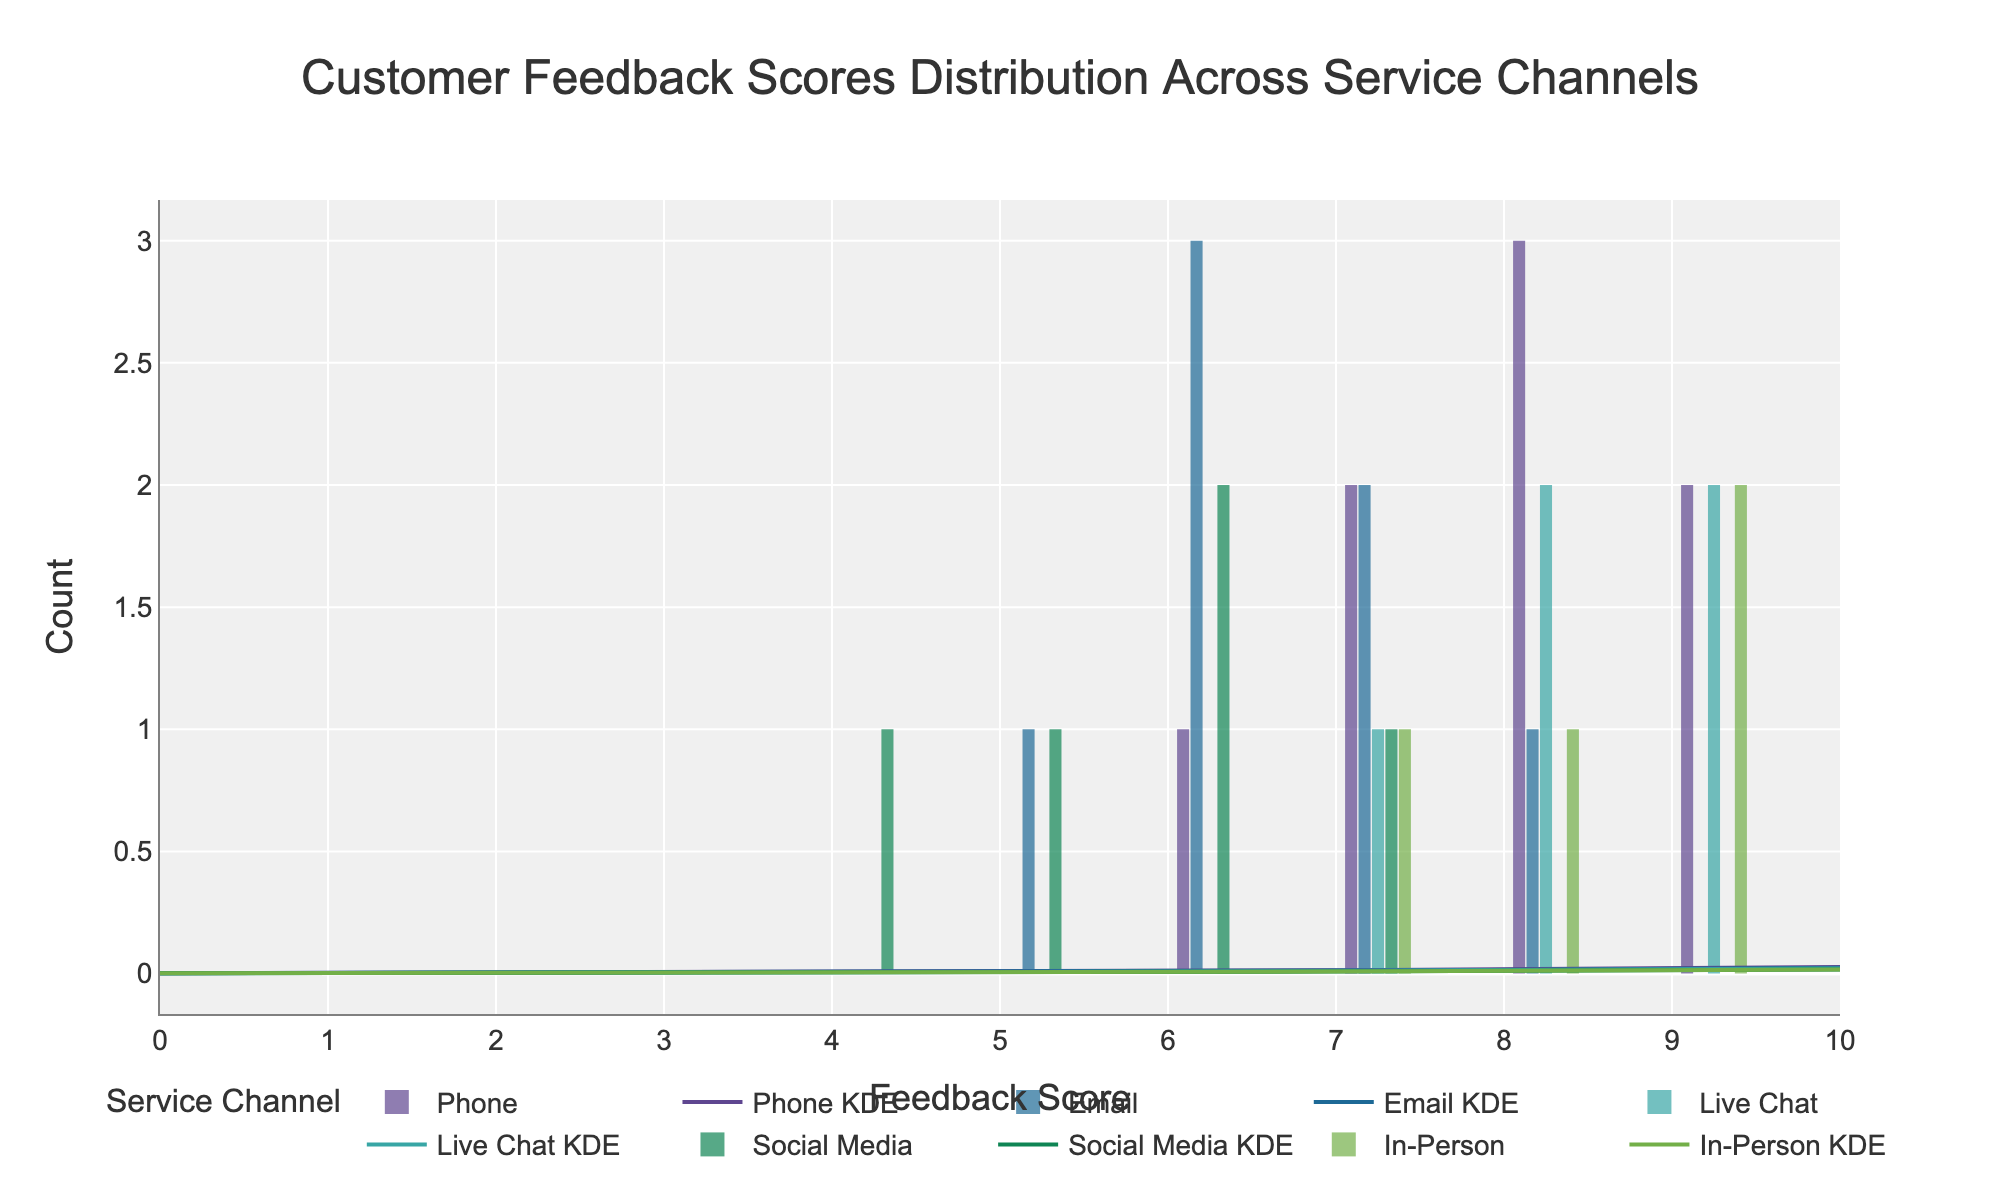What is the title of the figure? The title is located at the top center of the figure, which is in a bigger font size compared to other texts. It reads "Customer Feedback Scores Distribution Across Service Channels".
Answer: Customer Feedback Scores Distribution Across Service Channels What does the x-axis represent? The x-axis typically represents the variable being measured. In this figure, labeled as "Feedback Score", it corresponds to the scores given by customers to different service channels.
Answer: Feedback Score Which channel has the highest peak in the KDE (density curve)? To find the channel with the highest peak in the KDE, look at the tallest peak of each density curve plotted on the figure. It appears that the Live Chat channel has the highest peak.
Answer: Live Chat How many feedback scores were given in the Phone channel? Examine the histogram to find the total counts of data points in the Phone channel. There are visible bars for counts of feedback scores at different points across the x-axis. Summing these counts, we find it adds up to 8 scores.
Answer: 8 Which channel has the most spread out (wide) distribution of feedback scores? To determine the spread, observe the width of the KDE (density curve) for each channel. The Social Media channel has its KDE spread over a wider range of scores, indicating more variability.
Answer: Social Media What is the median feedback score for the Email channel? To find the median, identify the middle value of the sorted feedback scores for the Email channel. These scores are 5, 6, 6, 6, 7, 7, 8, thus the median score is the average of the two middle values, which is (6 + 6)/2 = 6.
Answer: 6 Which two channels have overlapping KDE curves most prominently in the mid-range of scores? Examine the KDE curves and notice where they overlap significantly. The Phone and Live Chat channels show notable overlap around scores of 7 to 8.
Answer: Phone and Live Chat Which channel has the lowest count of feedback scores for scores below 6? Look at the histogram bars for scores below 6. The figures show that Live Chat and In-Person channels have no bars below 6, thus they have the lowest count, which is zero.
Answer: Live Chat and In-Person Is the distribution of feedback scores for the In-Person channel skewed towards higher or lower scores? Analyze the histogram and KDE for the In-Person channel. The distribution is heavily skewed towards higher scores, as the bars and the KDE peak are more towards the higher end of the x-axis.
Answer: Higher scores 